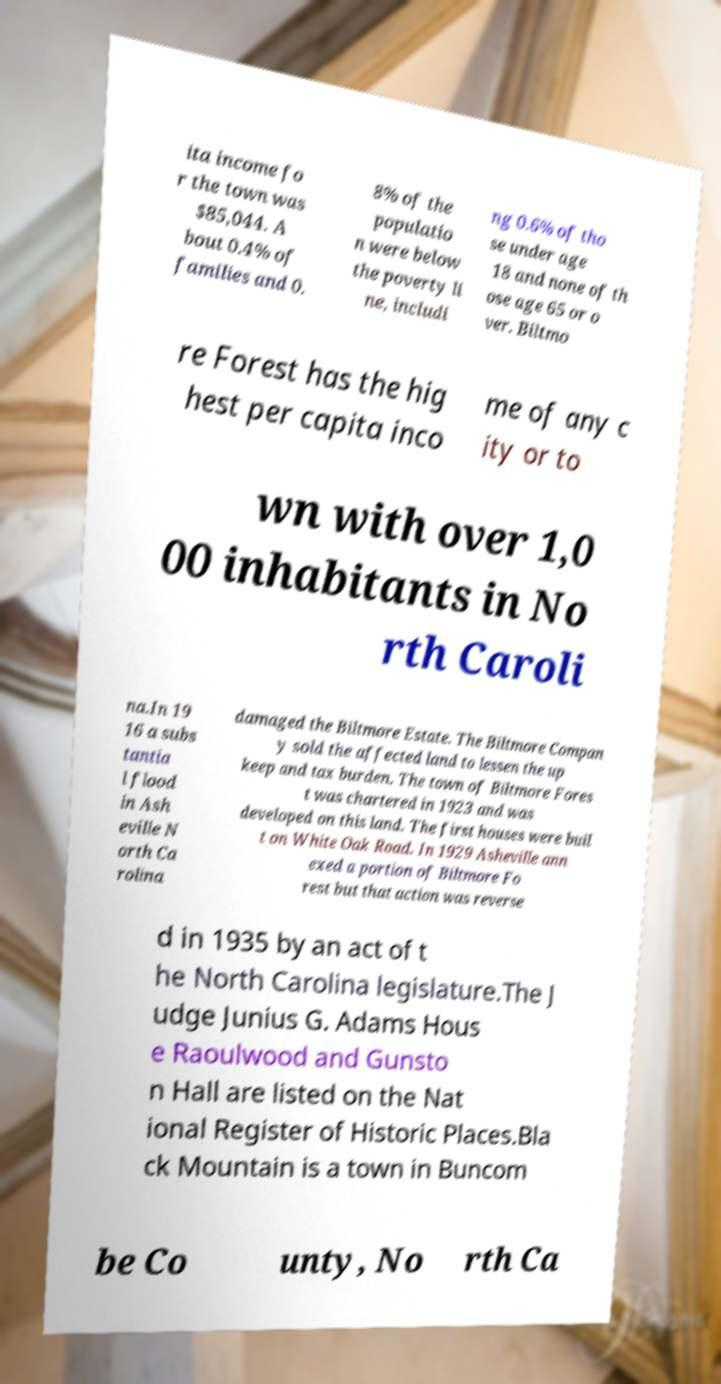There's text embedded in this image that I need extracted. Can you transcribe it verbatim? ita income fo r the town was $85,044. A bout 0.4% of families and 0. 8% of the populatio n were below the poverty li ne, includi ng 0.6% of tho se under age 18 and none of th ose age 65 or o ver. Biltmo re Forest has the hig hest per capita inco me of any c ity or to wn with over 1,0 00 inhabitants in No rth Caroli na.In 19 16 a subs tantia l flood in Ash eville N orth Ca rolina damaged the Biltmore Estate. The Biltmore Compan y sold the affected land to lessen the up keep and tax burden. The town of Biltmore Fores t was chartered in 1923 and was developed on this land. The first houses were buil t on White Oak Road. In 1929 Asheville ann exed a portion of Biltmore Fo rest but that action was reverse d in 1935 by an act of t he North Carolina legislature.The J udge Junius G. Adams Hous e Raoulwood and Gunsto n Hall are listed on the Nat ional Register of Historic Places.Bla ck Mountain is a town in Buncom be Co unty, No rth Ca 